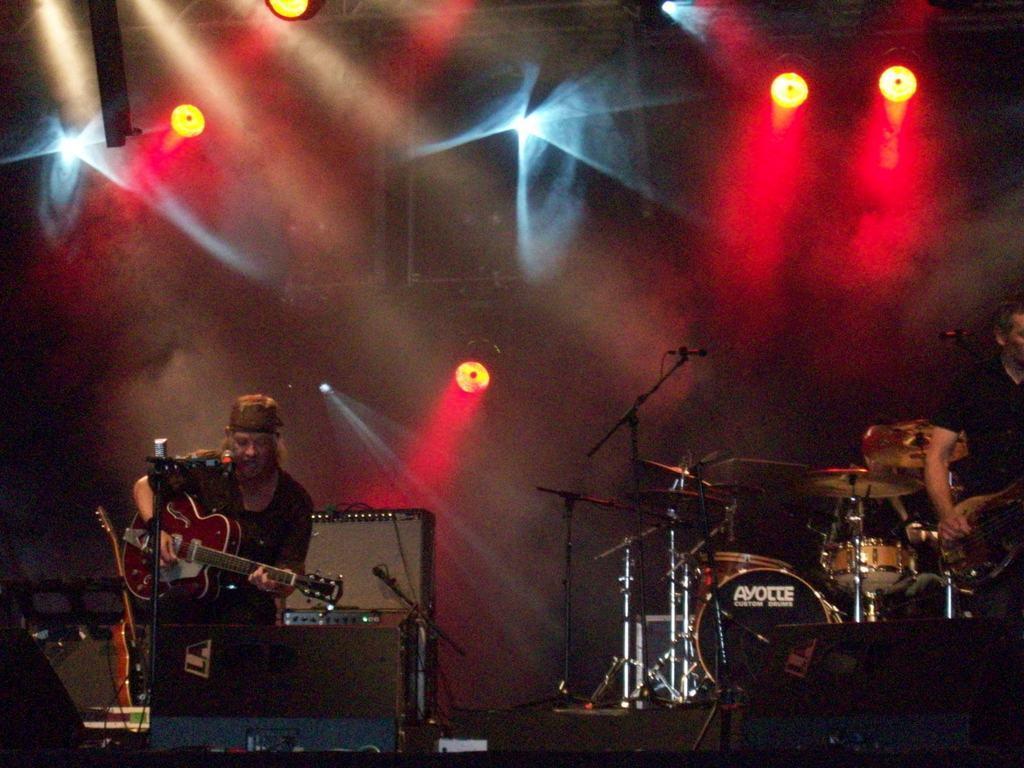How would you summarize this image in a sentence or two? A person is sitting on something and holding a guitar and playing. There is a drum, mic stand. In the background there are lights and some other equipment on the stage. 